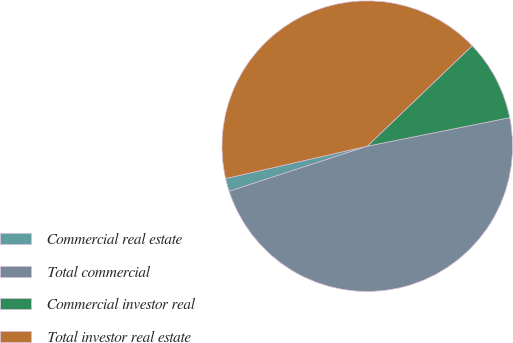<chart> <loc_0><loc_0><loc_500><loc_500><pie_chart><fcel>Commercial real estate<fcel>Total commercial<fcel>Commercial investor real<fcel>Total investor real estate<nl><fcel>1.45%<fcel>48.11%<fcel>9.01%<fcel>41.42%<nl></chart> 